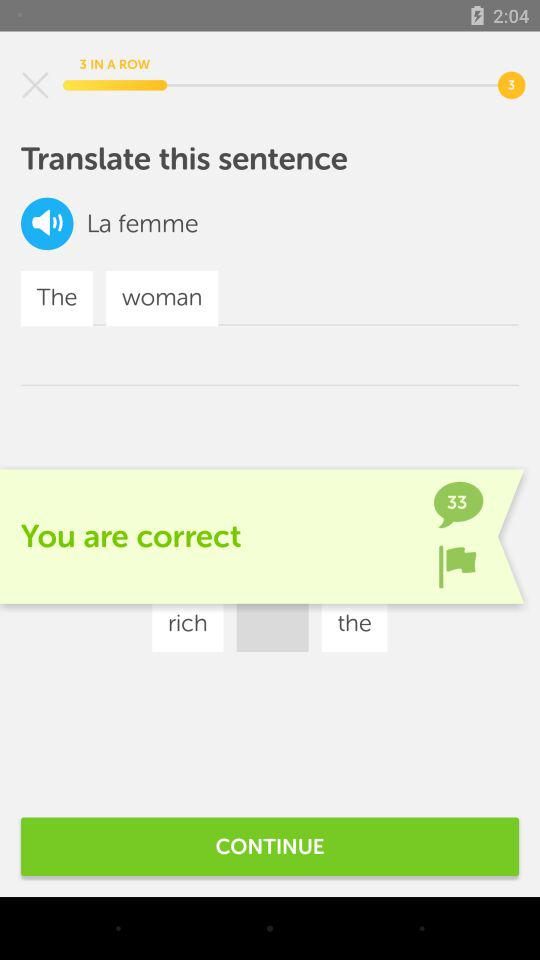How many times have I got it right in a row? You have got it right 3 times in a row. 